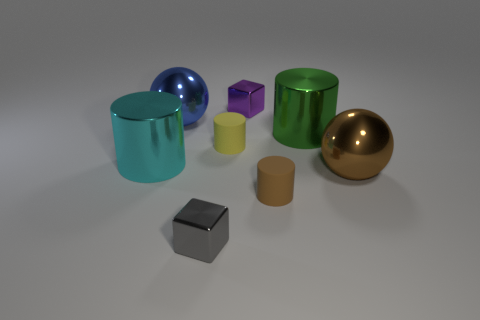Could you describe the colors and materials of the objects present in the image? The image displays a variety of objects with different colors and materials. There's a reflective blue sphere and a reflective golden sphere, two shiny cyan cylinders, a matte purple cube, a shiny green cylinder, a matte yellow cylinder, a matte brown cylinder, and a matte black cube. Each object showcases unique material characteristics, contributing to a vibrant visual diversity. 